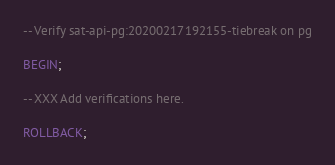<code> <loc_0><loc_0><loc_500><loc_500><_SQL_>-- Verify sat-api-pg:20200217192155-tiebreak on pg

BEGIN;

-- XXX Add verifications here.

ROLLBACK;
</code> 